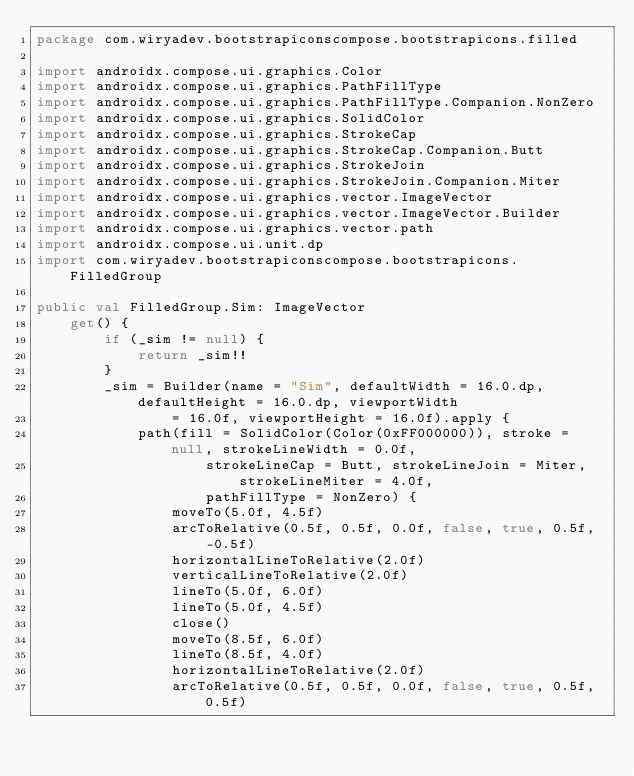Convert code to text. <code><loc_0><loc_0><loc_500><loc_500><_Kotlin_>package com.wiryadev.bootstrapiconscompose.bootstrapicons.filled

import androidx.compose.ui.graphics.Color
import androidx.compose.ui.graphics.PathFillType
import androidx.compose.ui.graphics.PathFillType.Companion.NonZero
import androidx.compose.ui.graphics.SolidColor
import androidx.compose.ui.graphics.StrokeCap
import androidx.compose.ui.graphics.StrokeCap.Companion.Butt
import androidx.compose.ui.graphics.StrokeJoin
import androidx.compose.ui.graphics.StrokeJoin.Companion.Miter
import androidx.compose.ui.graphics.vector.ImageVector
import androidx.compose.ui.graphics.vector.ImageVector.Builder
import androidx.compose.ui.graphics.vector.path
import androidx.compose.ui.unit.dp
import com.wiryadev.bootstrapiconscompose.bootstrapicons.FilledGroup

public val FilledGroup.Sim: ImageVector
    get() {
        if (_sim != null) {
            return _sim!!
        }
        _sim = Builder(name = "Sim", defaultWidth = 16.0.dp, defaultHeight = 16.0.dp, viewportWidth
                = 16.0f, viewportHeight = 16.0f).apply {
            path(fill = SolidColor(Color(0xFF000000)), stroke = null, strokeLineWidth = 0.0f,
                    strokeLineCap = Butt, strokeLineJoin = Miter, strokeLineMiter = 4.0f,
                    pathFillType = NonZero) {
                moveTo(5.0f, 4.5f)
                arcToRelative(0.5f, 0.5f, 0.0f, false, true, 0.5f, -0.5f)
                horizontalLineToRelative(2.0f)
                verticalLineToRelative(2.0f)
                lineTo(5.0f, 6.0f)
                lineTo(5.0f, 4.5f)
                close()
                moveTo(8.5f, 6.0f)
                lineTo(8.5f, 4.0f)
                horizontalLineToRelative(2.0f)
                arcToRelative(0.5f, 0.5f, 0.0f, false, true, 0.5f, 0.5f)</code> 